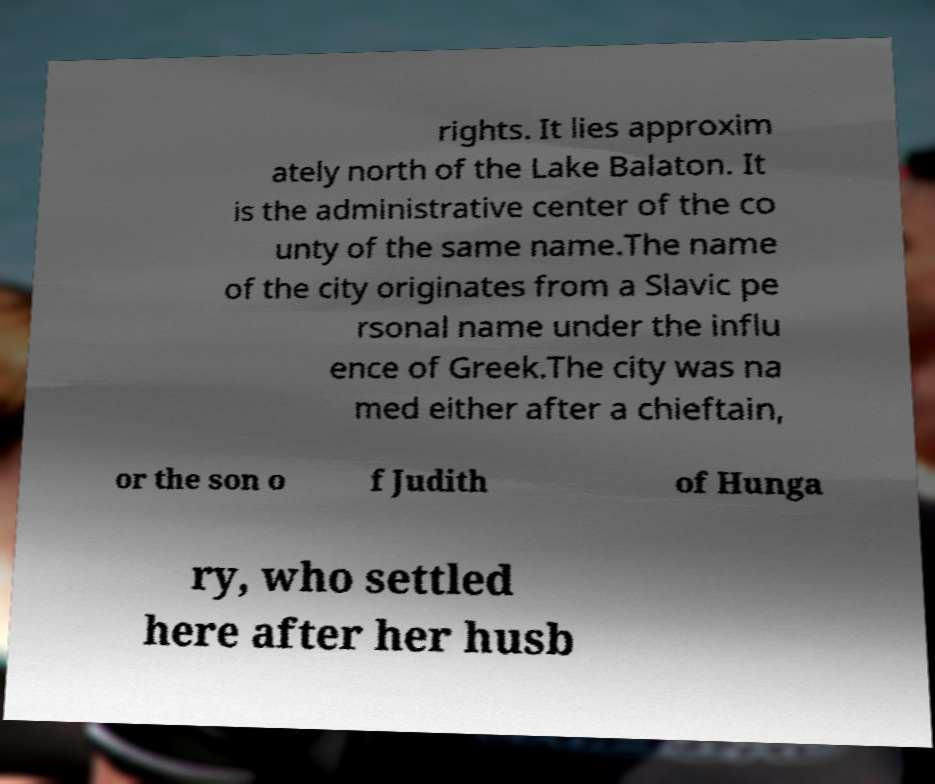I need the written content from this picture converted into text. Can you do that? rights. It lies approxim ately north of the Lake Balaton. It is the administrative center of the co unty of the same name.The name of the city originates from a Slavic pe rsonal name under the influ ence of Greek.The city was na med either after a chieftain, or the son o f Judith of Hunga ry, who settled here after her husb 